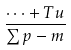Convert formula to latex. <formula><loc_0><loc_0><loc_500><loc_500>\frac { { \cdots + { T u } } } { \sum { p - m } }</formula> 